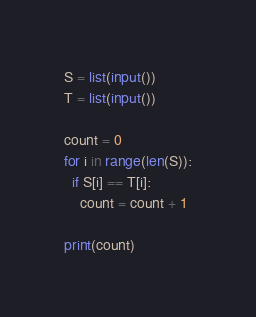<code> <loc_0><loc_0><loc_500><loc_500><_Python_>S = list(input())
T = list(input())

count = 0
for i in range(len(S)):
  if S[i] == T[i]:
    count = count + 1
    
print(count)</code> 